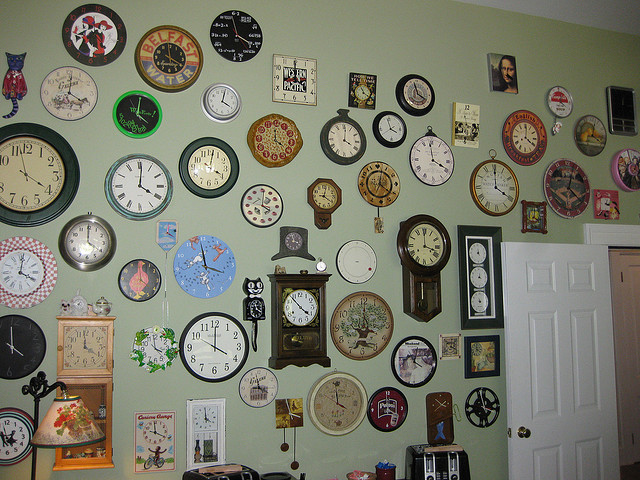Is the door open or closed? The door is open, as evident from the visible gap between the door and its frame. 